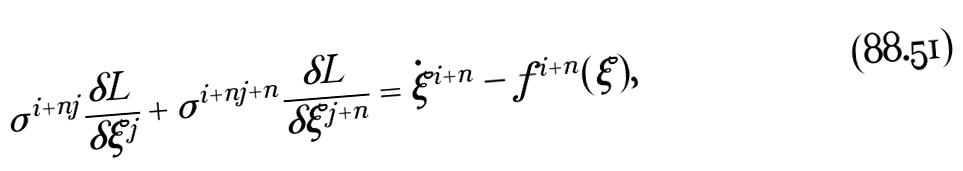Convert formula to latex. <formula><loc_0><loc_0><loc_500><loc_500>\sigma ^ { i + n j } \frac { \delta L } { \delta \xi ^ { j } } + \sigma ^ { i + n j + n } \frac { \delta L } { \delta \xi ^ { j + n } } = \dot { \xi } ^ { i + n } - f ^ { i + n } ( \xi ) ,</formula> 